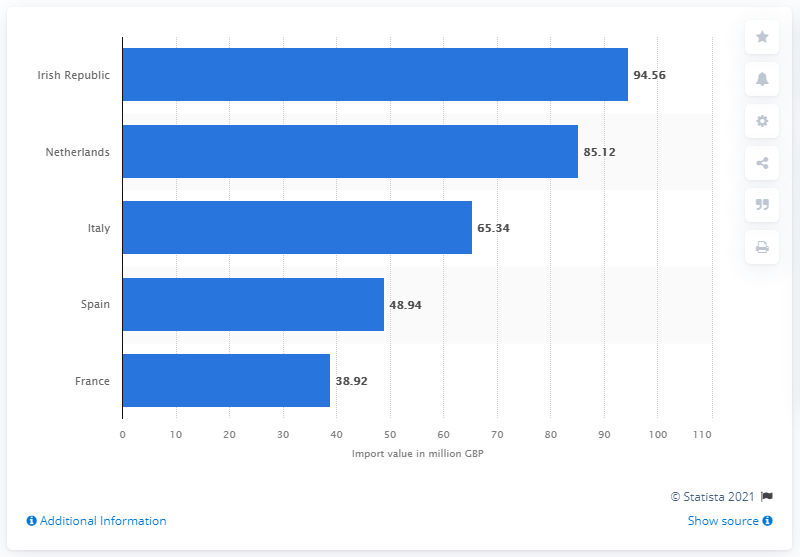Specify some key components in this picture. In 2020, the value of beer imports from Ireland was 94.56. In 2020, the value of beer imports from the Netherlands was 85.12.. 